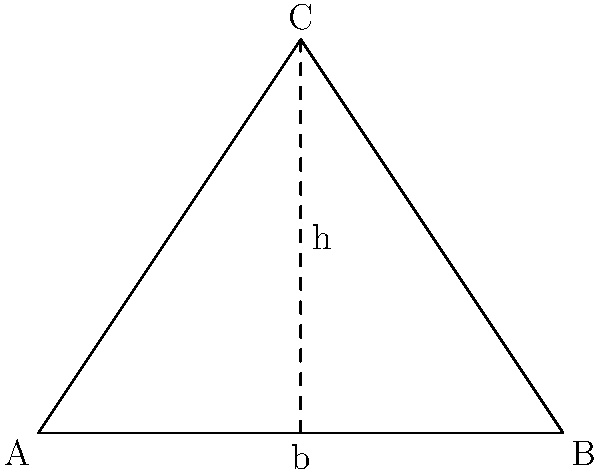Based on the geometric shape of the Savannah River point shown in the diagram, what is the formula for calculating its area? To calculate the area of the Savannah River point, we need to follow these steps:

1. Recognize the shape: The Savannah River point is typically triangular in shape, as shown in the diagram.

2. Recall the formula for the area of a triangle: The area of a triangle is given by the formula $A = \frac{1}{2} \times base \times height$.

3. Identify the base and height:
   - The base (b) is the bottom side of the triangle (AB in the diagram).
   - The height (h) is the perpendicular distance from the base to the opposite vertex (C in the diagram).

4. Apply the formula: The area of the Savannah River point can be calculated using $A = \frac{1}{2} \times b \times h$, where:
   - A is the area
   - b is the length of the base
   - h is the height of the triangle

Therefore, the formula for calculating the area of the Savannah River point, based on its geometric shape, is $A = \frac{1}{2} \times b \times h$.
Answer: $A = \frac{1}{2} \times b \times h$ 